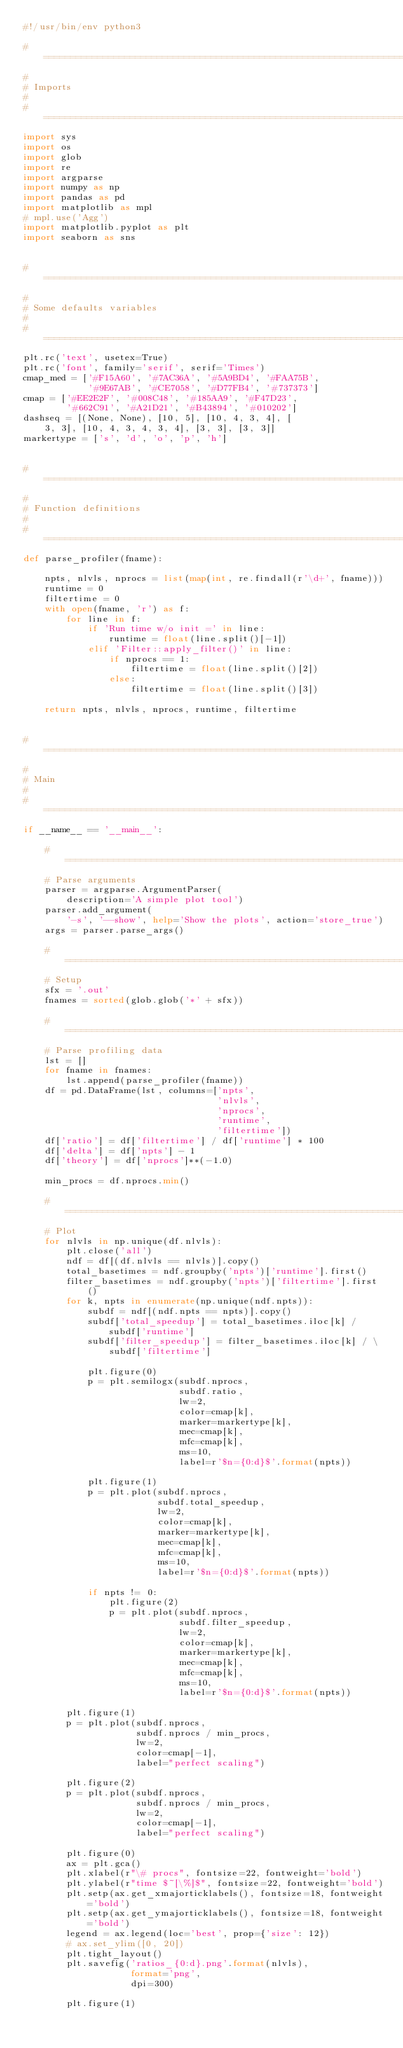Convert code to text. <code><loc_0><loc_0><loc_500><loc_500><_Python_>#!/usr/bin/env python3

# ========================================================================
#
# Imports
#
# ========================================================================
import sys
import os
import glob
import re
import argparse
import numpy as np
import pandas as pd
import matplotlib as mpl
# mpl.use('Agg')
import matplotlib.pyplot as plt
import seaborn as sns


# ========================================================================
#
# Some defaults variables
#
# ========================================================================
plt.rc('text', usetex=True)
plt.rc('font', family='serif', serif='Times')
cmap_med = ['#F15A60', '#7AC36A', '#5A9BD4', '#FAA75B',
            '#9E67AB', '#CE7058', '#D77FB4', '#737373']
cmap = ['#EE2E2F', '#008C48', '#185AA9', '#F47D23',
        '#662C91', '#A21D21', '#B43894', '#010202']
dashseq = [(None, None), [10, 5], [10, 4, 3, 4], [
    3, 3], [10, 4, 3, 4, 3, 4], [3, 3], [3, 3]]
markertype = ['s', 'd', 'o', 'p', 'h']


# ========================================================================
#
# Function definitions
#
# ========================================================================
def parse_profiler(fname):

    npts, nlvls, nprocs = list(map(int, re.findall(r'\d+', fname)))
    runtime = 0
    filtertime = 0
    with open(fname, 'r') as f:
        for line in f:
            if 'Run time w/o init =' in line:
                runtime = float(line.split()[-1])
            elif 'Filter::apply_filter()' in line:
                if nprocs == 1:
                    filtertime = float(line.split()[2])
                else:
                    filtertime = float(line.split()[3])

    return npts, nlvls, nprocs, runtime, filtertime


# ========================================================================
#
# Main
#
# ========================================================================
if __name__ == '__main__':

    # ========================================================================
    # Parse arguments
    parser = argparse.ArgumentParser(
        description='A simple plot tool')
    parser.add_argument(
        '-s', '--show', help='Show the plots', action='store_true')
    args = parser.parse_args()

    # ========================================================================
    # Setup
    sfx = '.out'
    fnames = sorted(glob.glob('*' + sfx))

    # ========================================================================
    # Parse profiling data
    lst = []
    for fname in fnames:
        lst.append(parse_profiler(fname))
    df = pd.DataFrame(lst, columns=['npts',
                                    'nlvls',
                                    'nprocs',
                                    'runtime',
                                    'filtertime'])
    df['ratio'] = df['filtertime'] / df['runtime'] * 100
    df['delta'] = df['npts'] - 1
    df['theory'] = df['nprocs']**(-1.0)

    min_procs = df.nprocs.min()

    # ========================================================================
    # Plot
    for nlvls in np.unique(df.nlvls):
        plt.close('all')
        ndf = df[(df.nlvls == nlvls)].copy()
        total_basetimes = ndf.groupby('npts')['runtime'].first()
        filter_basetimes = ndf.groupby('npts')['filtertime'].first()
        for k, npts in enumerate(np.unique(ndf.npts)):
            subdf = ndf[(ndf.npts == npts)].copy()
            subdf['total_speedup'] = total_basetimes.iloc[k] / subdf['runtime']
            subdf['filter_speedup'] = filter_basetimes.iloc[k] / \
                subdf['filtertime']

            plt.figure(0)
            p = plt.semilogx(subdf.nprocs,
                             subdf.ratio,
                             lw=2,
                             color=cmap[k],
                             marker=markertype[k],
                             mec=cmap[k],
                             mfc=cmap[k],
                             ms=10,
                             label=r'$n={0:d}$'.format(npts))

            plt.figure(1)
            p = plt.plot(subdf.nprocs,
                         subdf.total_speedup,
                         lw=2,
                         color=cmap[k],
                         marker=markertype[k],
                         mec=cmap[k],
                         mfc=cmap[k],
                         ms=10,
                         label=r'$n={0:d}$'.format(npts))

            if npts != 0:
                plt.figure(2)
                p = plt.plot(subdf.nprocs,
                             subdf.filter_speedup,
                             lw=2,
                             color=cmap[k],
                             marker=markertype[k],
                             mec=cmap[k],
                             mfc=cmap[k],
                             ms=10,
                             label=r'$n={0:d}$'.format(npts))

        plt.figure(1)
        p = plt.plot(subdf.nprocs,
                     subdf.nprocs / min_procs,
                     lw=2,
                     color=cmap[-1],
                     label="perfect scaling")

        plt.figure(2)
        p = plt.plot(subdf.nprocs,
                     subdf.nprocs / min_procs,
                     lw=2,
                     color=cmap[-1],
                     label="perfect scaling")

        plt.figure(0)
        ax = plt.gca()
        plt.xlabel(r"\# procs", fontsize=22, fontweight='bold')
        plt.ylabel(r"time $~[\%]$", fontsize=22, fontweight='bold')
        plt.setp(ax.get_xmajorticklabels(), fontsize=18, fontweight='bold')
        plt.setp(ax.get_ymajorticklabels(), fontsize=18, fontweight='bold')
        legend = ax.legend(loc='best', prop={'size': 12})
        # ax.set_ylim([0, 20])
        plt.tight_layout()
        plt.savefig('ratios_{0:d}.png'.format(nlvls),
                    format='png',
                    dpi=300)

        plt.figure(1)</code> 